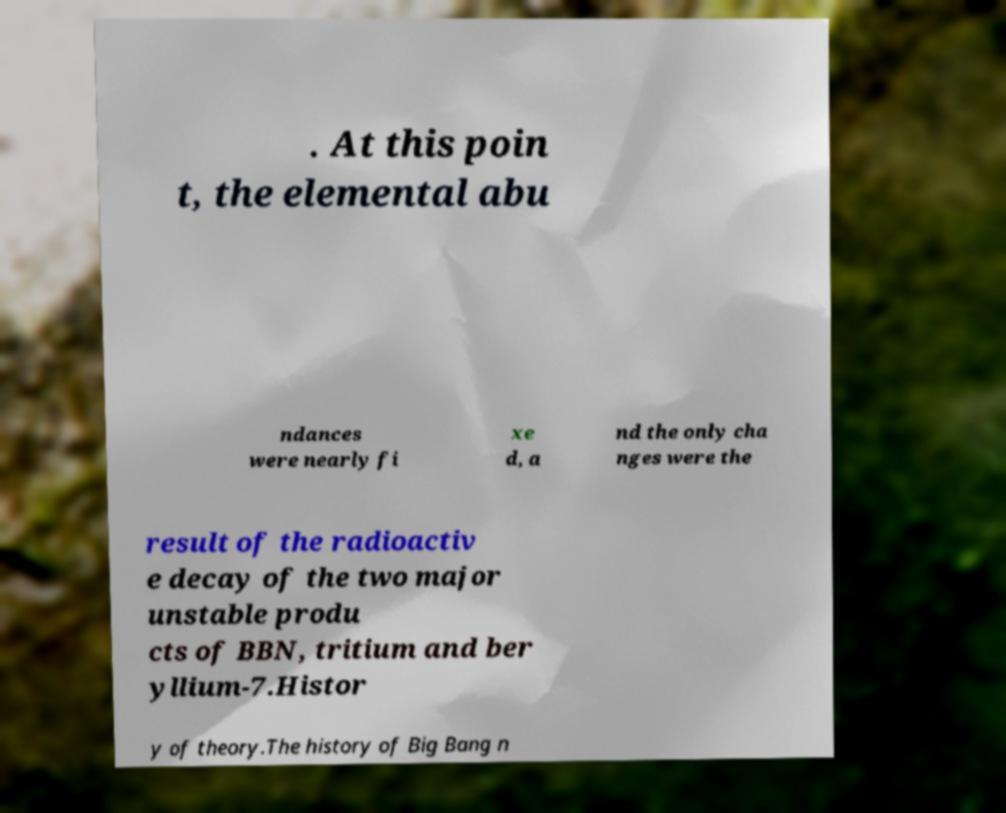Can you read and provide the text displayed in the image?This photo seems to have some interesting text. Can you extract and type it out for me? . At this poin t, the elemental abu ndances were nearly fi xe d, a nd the only cha nges were the result of the radioactiv e decay of the two major unstable produ cts of BBN, tritium and ber yllium-7.Histor y of theory.The history of Big Bang n 